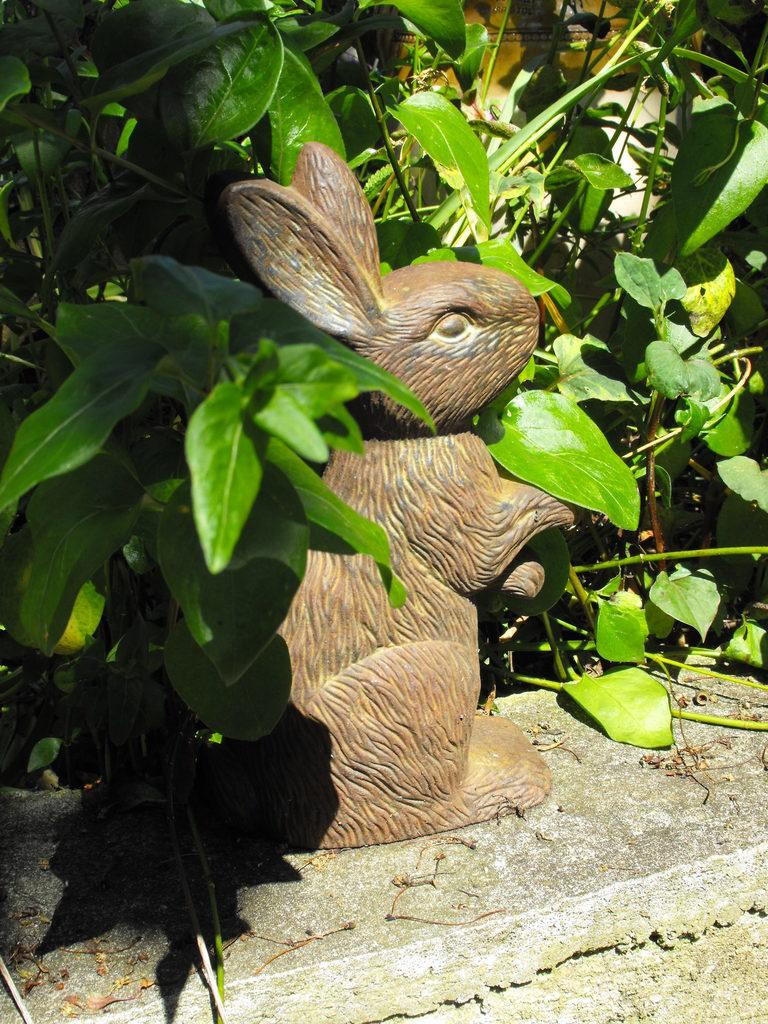What is the main subject in the image? There is a statue in the image. What else can be seen in the image besides the statue? Plants are visible in the image. What type of locket is the grandfather wearing in the image? There is no grandfather or locket present in the image; it only features a statue and plants. 